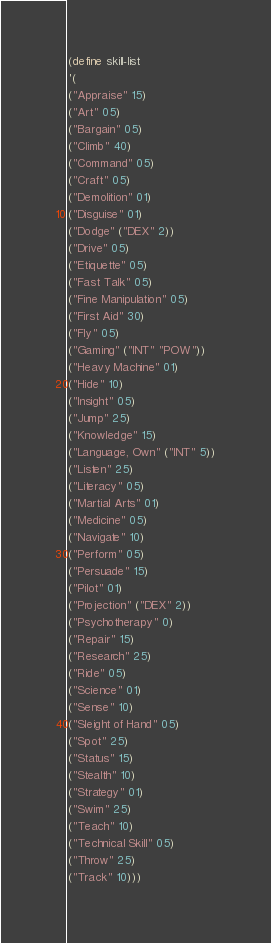<code> <loc_0><loc_0><loc_500><loc_500><_Scheme_>(define skill-list
'(
("Appraise" 15)
("Art" 05)
("Bargain" 05)
("Climb" 40)
("Command" 05)
("Craft" 05)
("Demolition" 01)
("Disguise" 01)
("Dodge" ("DEX" 2))
("Drive" 05)
("Etiquette" 05)
("Fast Talk" 05)
("Fine Manipulation" 05)
("First Aid" 30)
("Fly" 05)
("Gaming" ("INT" "POW"))
("Heavy Machine" 01)
("Hide" 10)
("Insight" 05)
("Jump" 25)
("Knowledge" 15)
("Language, Own" ("INT" 5))
("Listen" 25)
("Literacy" 05)
("Martial Arts" 01)
("Medicine" 05)
("Navigate" 10)
("Perform" 05)
("Persuade" 15)
("Pilot" 01)
("Projection" ("DEX" 2))
("Psychotherapy" 0)
("Repair" 15)
("Research" 25)
("Ride" 05)
("Science" 01)
("Sense" 10)
("Sleight of Hand" 05)
("Spot" 25)
("Status" 15)
("Stealth" 10)
("Strategy" 01)
("Swim" 25)
("Teach" 10)
("Technical Skill" 05)
("Throw" 25)
("Track" 10)))
</code> 